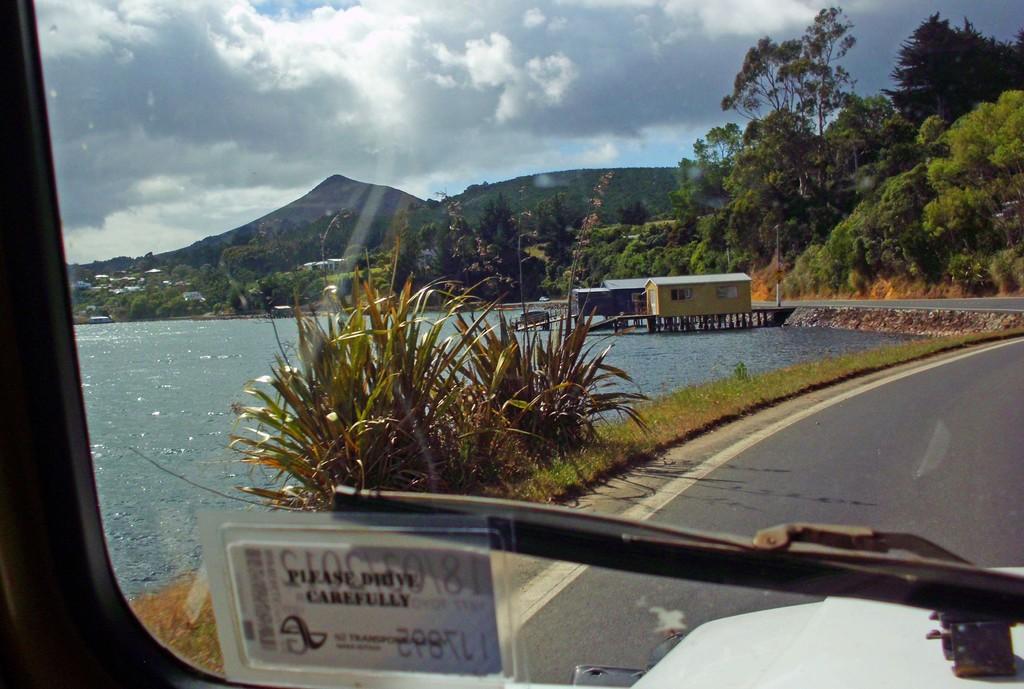Please provide a concise description of this image. Completely an outdoor picture. Sky is cloudy and it is in white color. This is a river. River has fresh water. Plants. Grass is in green color. Far there are house on river. Far there are mountains and hills. Trees are in green color. Road. A vehicle wiper. 